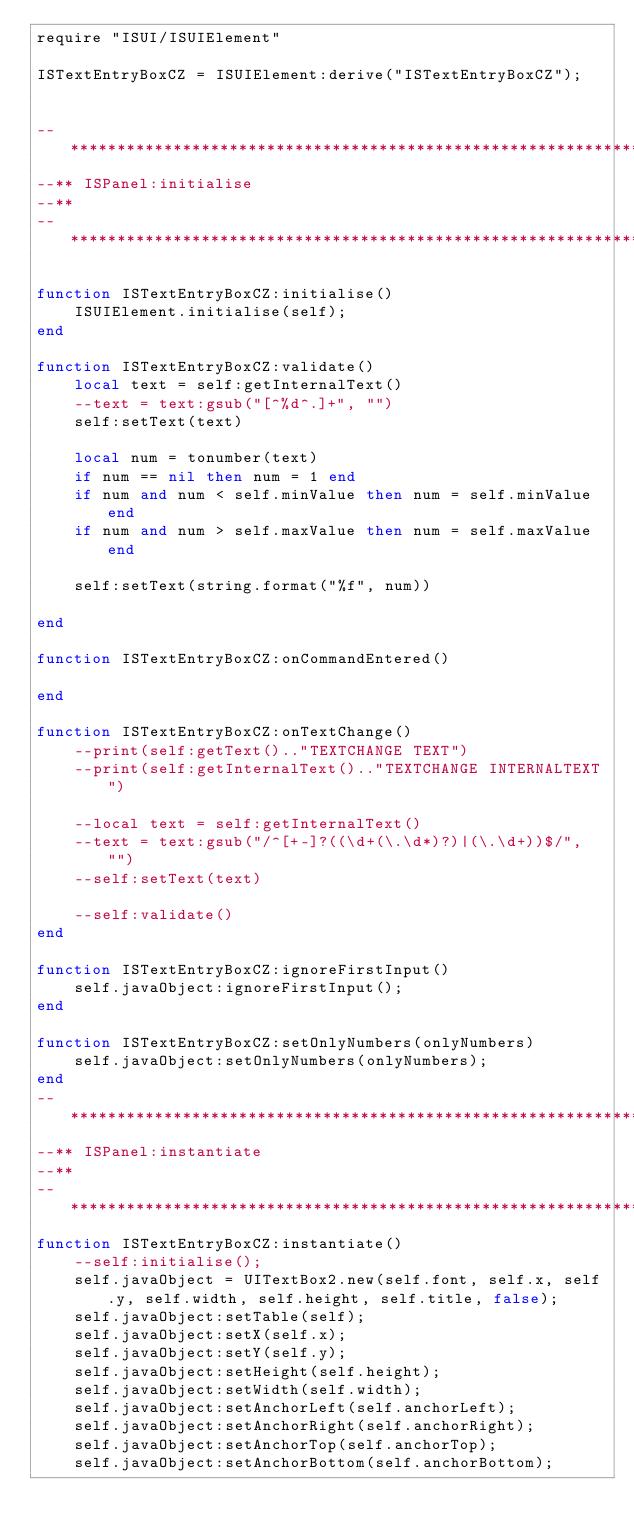<code> <loc_0><loc_0><loc_500><loc_500><_Lua_>require "ISUI/ISUIElement"

ISTextEntryBoxCZ = ISUIElement:derive("ISTextEntryBoxCZ");


--************************************************************************--
--** ISPanel:initialise
--**
--************************************************************************--

function ISTextEntryBoxCZ:initialise()
	ISUIElement.initialise(self);
end

function ISTextEntryBoxCZ:validate()
    local text = self:getInternalText()
    --text = text:gsub("[^%d^.]+", "")
    self:setText(text)
    
	local num = tonumber(text)
	if num == nil then num = 1 end
	if num and num < self.minValue then num = self.minValue end
	if num and num > self.maxValue then num = self.maxValue end
	
	self:setText(string.format("%f", num))
	
end

function ISTextEntryBoxCZ:onCommandEntered()
    
end

function ISTextEntryBoxCZ:onTextChange()
    --print(self:getText().."TEXTCHANGE TEXT")
    --print(self:getInternalText().."TEXTCHANGE INTERNALTEXT")
	
	--local text = self:getInternalText()
    --text = text:gsub("/^[+-]?((\d+(\.\d*)?)|(\.\d+))$/", "")
	--self:setText(text)
	
    --self:validate()
end

function ISTextEntryBoxCZ:ignoreFirstInput()
	self.javaObject:ignoreFirstInput();
end

function ISTextEntryBoxCZ:setOnlyNumbers(onlyNumbers)
    self.javaObject:setOnlyNumbers(onlyNumbers);
end
--************************************************************************--
--** ISPanel:instantiate
--**
--************************************************************************--
function ISTextEntryBoxCZ:instantiate()
	--self:initialise();
	self.javaObject = UITextBox2.new(self.font, self.x, self.y, self.width, self.height, self.title, false);
	self.javaObject:setTable(self);
	self.javaObject:setX(self.x);
	self.javaObject:setY(self.y);
	self.javaObject:setHeight(self.height);
	self.javaObject:setWidth(self.width);
	self.javaObject:setAnchorLeft(self.anchorLeft);
	self.javaObject:setAnchorRight(self.anchorRight);
	self.javaObject:setAnchorTop(self.anchorTop);
	self.javaObject:setAnchorBottom(self.anchorBottom);</code> 